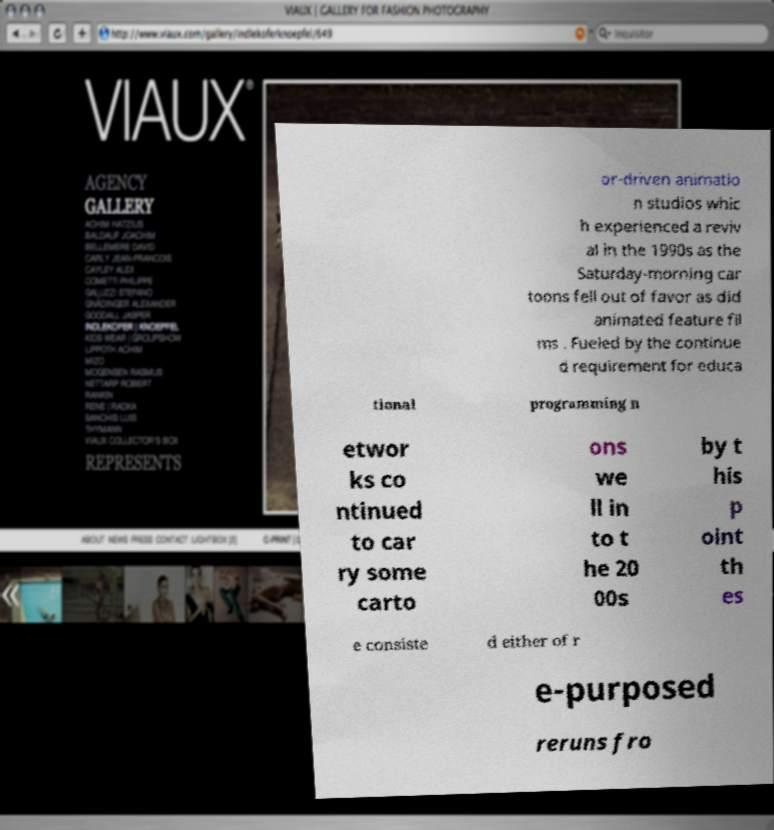For documentation purposes, I need the text within this image transcribed. Could you provide that? or-driven animatio n studios whic h experienced a reviv al in the 1990s as the Saturday-morning car toons fell out of favor as did animated feature fil ms . Fueled by the continue d requirement for educa tional programming n etwor ks co ntinued to car ry some carto ons we ll in to t he 20 00s by t his p oint th es e consiste d either of r e-purposed reruns fro 